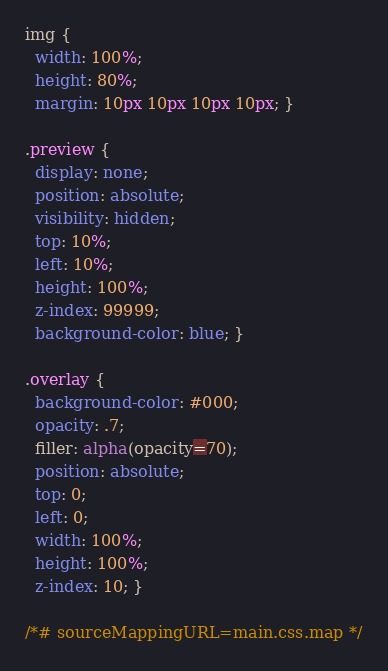<code> <loc_0><loc_0><loc_500><loc_500><_CSS_>img {
  width: 100%;
  height: 80%;
  margin: 10px 10px 10px 10px; }

.preview {
  display: none;
  position: absolute;
  visibility: hidden;
  top: 10%;
  left: 10%;
  height: 100%;
  z-index: 99999;
  background-color: blue; }

.overlay {
  background-color: #000;
  opacity: .7;
  filler: alpha(opacity=70);
  position: absolute;
  top: 0;
  left: 0;
  width: 100%;
  height: 100%;
  z-index: 10; }

/*# sourceMappingURL=main.css.map */
</code> 